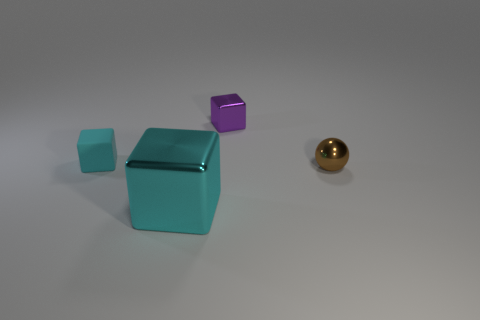Is there any other thing that has the same color as the small metal ball? Upon examining the image, it appears that there are no other objects sharing the exact same color tone as the small metal ball which has a distinct polished gold hue. The other objects visible comprise a large teal box, a smaller piece resembling it, and a smaller purple cube, each presenting unique colors. 